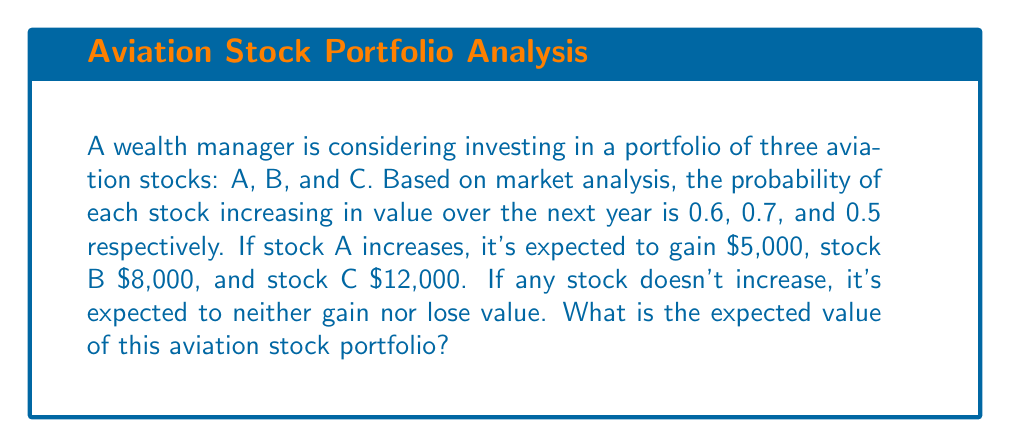Provide a solution to this math problem. To solve this problem, we need to calculate the expected value for each stock and then sum them up:

1. For Stock A:
   Probability of increase = 0.6
   Expected gain if increased = $5,000
   Expected value = $5,000 * 0.6 + $0 * 0.4 = $3,000

2. For Stock B:
   Probability of increase = 0.7
   Expected gain if increased = $8,000
   Expected value = $8,000 * 0.7 + $0 * 0.3 = $5,600

3. For Stock C:
   Probability of increase = 0.5
   Expected gain if increased = $12,000
   Expected value = $12,000 * 0.5 + $0 * 0.5 = $6,000

The expected value of the portfolio is the sum of the expected values of each stock:

$$ E(\text{Portfolio}) = E(A) + E(B) + E(C) $$
$$ E(\text{Portfolio}) = $3,000 + $5,600 + $6,000 = $14,600 $$

Therefore, the expected value of the aviation stock portfolio is $14,600.
Answer: $14,600 